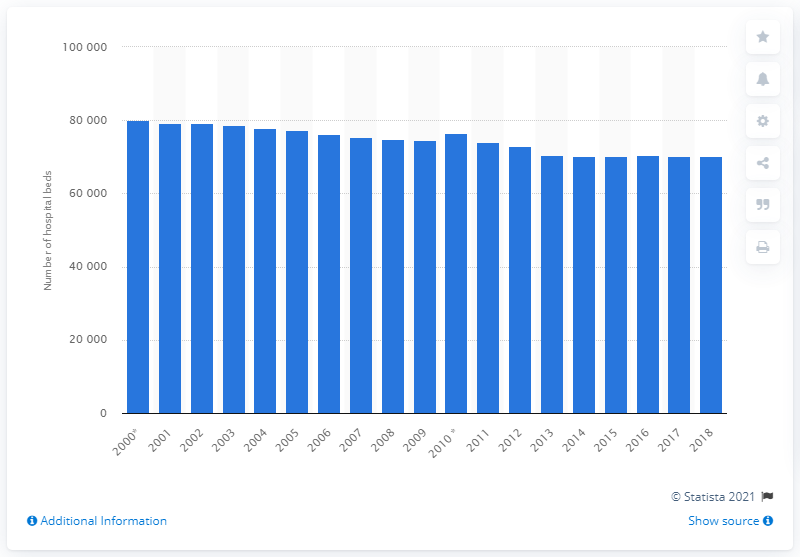Mention a couple of crucial points in this snapshot. In 2018, there were 70,351 hospital beds available in the Czech Republic. 